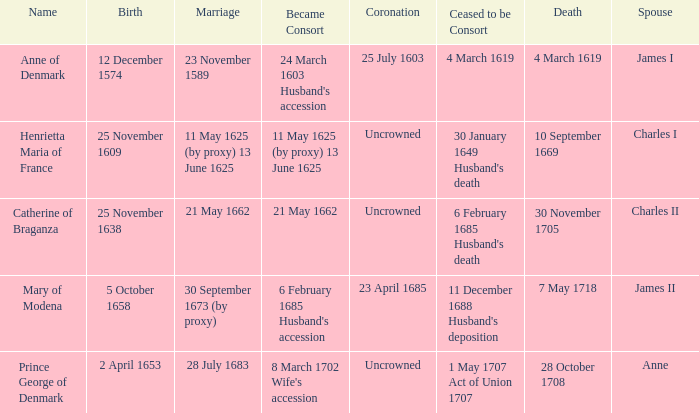On what date did James II take a consort? 6 February 1685 Husband's accession. 